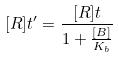Convert formula to latex. <formula><loc_0><loc_0><loc_500><loc_500>[ R ] t ^ { \prime } = \frac { [ R ] t } { 1 + \frac { [ B ] } { K _ { b } } }</formula> 